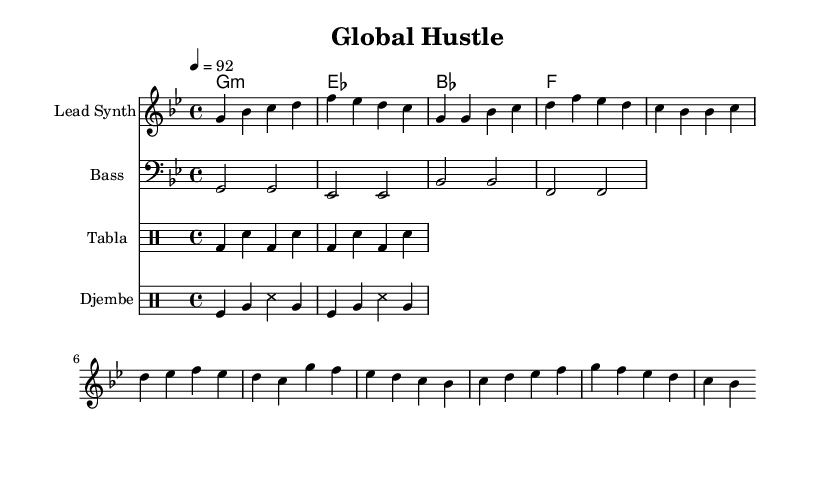What is the key signature of this music? The key signature indicates that the music is in G minor, which has two flats (B flat and E flat). This can be determined by looking at the start of the music where the key signature is indicated.
Answer: G minor What is the time signature of this music? The time signature is found at the beginning of the music, which displays that the music is in 4/4 time. This means there are four beats in each measure, and the quarter note gets one beat.
Answer: 4/4 What is the tempo marking in this piece? The tempo marking is indicated as "4 = 92," meaning there are 92 beats per minute when played at a quarter note pace. This helps establish the overall speed of the piece.
Answer: 92 How many measures are in the chorus section? To find the number of measures, we can focus on the notes provided under the chorus section, which contains four measures of music. Each measure is separated by a vertical bar.
Answer: 4 What instruments are featured in this composition? From the score, we can see that the composition includes a lead synth, a bass, and two types of drums: tabla and djembe. This is indicated by the different staves labeled with the instrument names.
Answer: Lead Synth, Bass, Tabla, Djembe What role does the tabla play in this piece? The tabla is used to provide a rhythmic foundation with specified bass and snare patterns. This adds a traditional world music element to the fusion with hip-hop, as indicated by the drumming pattern written in the percussion staff.
Answer: Rhythmic foundation What is the theme reflected in the music? The themes of teamwork and perseverance are expressed through the collaborative elements of different instruments and the rhythmic drive created by the fusion of hip-hop with world music. The ensemble aspect suggests a collective effort.
Answer: Teamwork and perseverance 